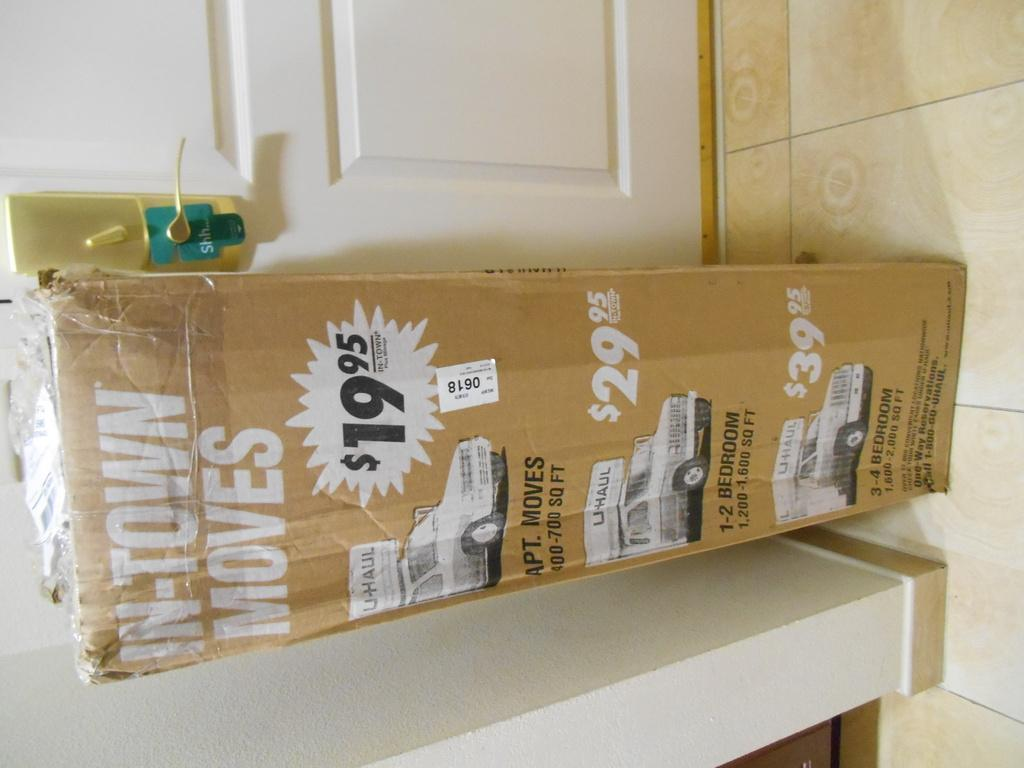<image>
Write a terse but informative summary of the picture. A U-Haul box says "in-town moves" on it and lists different truck sizes. 